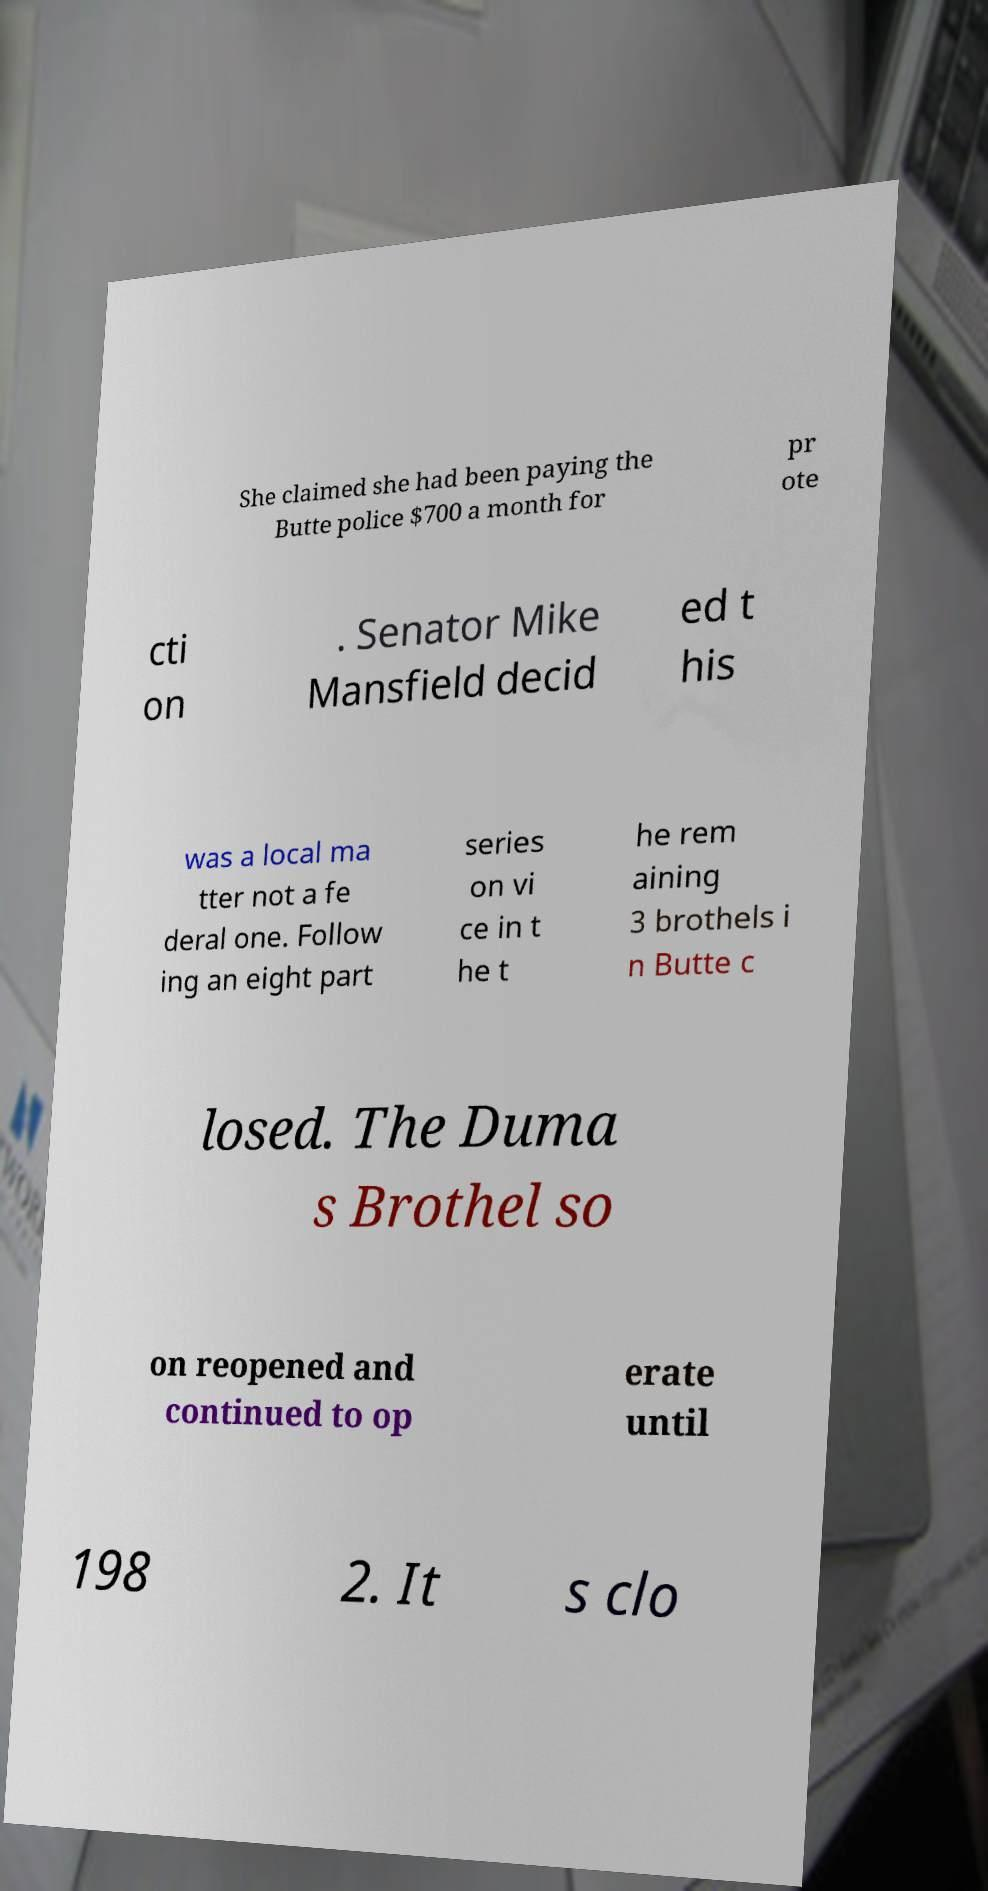Please identify and transcribe the text found in this image. She claimed she had been paying the Butte police $700 a month for pr ote cti on . Senator Mike Mansfield decid ed t his was a local ma tter not a fe deral one. Follow ing an eight part series on vi ce in t he t he rem aining 3 brothels i n Butte c losed. The Duma s Brothel so on reopened and continued to op erate until 198 2. It s clo 